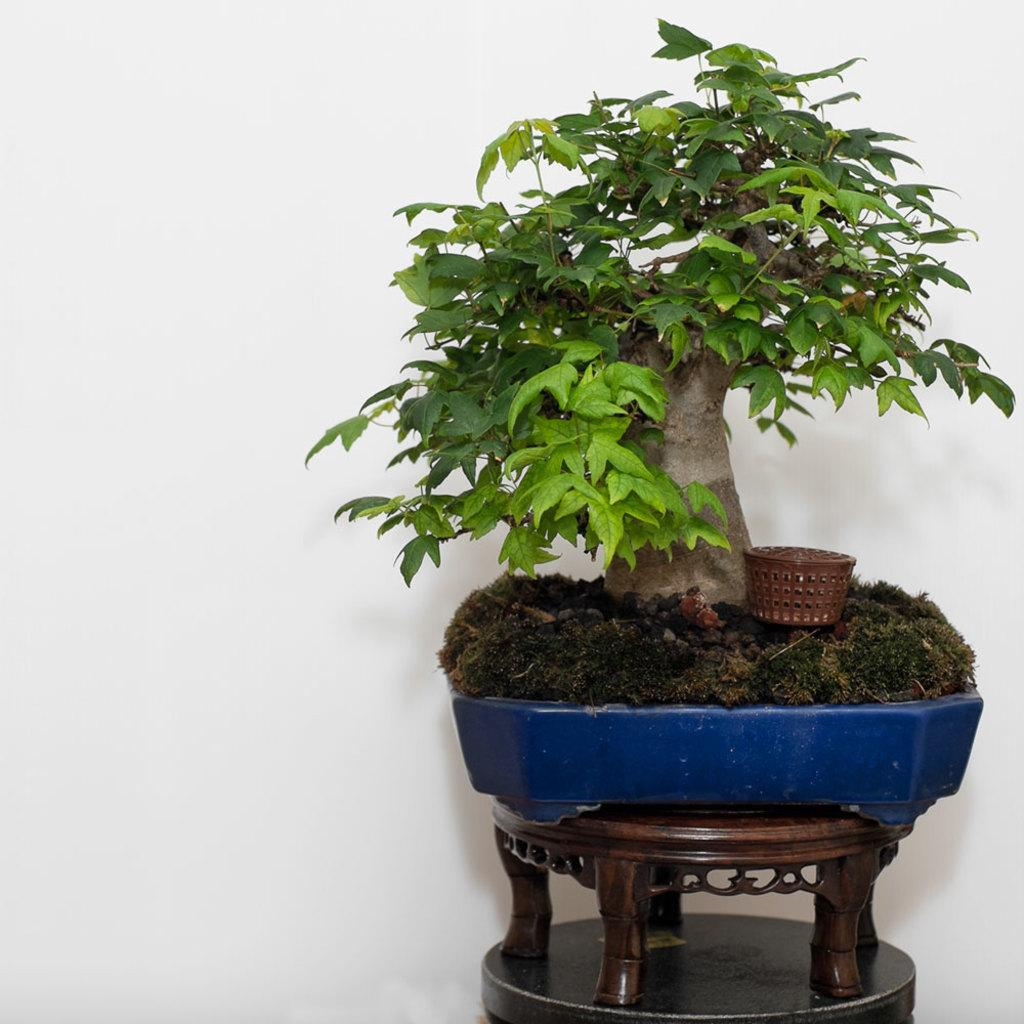What type of plant is in the pot in the image? There is a bonsai plant in the pot in the image. How is the pot with the bonsai plant positioned? The pot is on a stand. What other object is near the bonsai plant? There is a small box near the plant. What can be seen in the background of the image? There is a wall in the background of the image. How many firemen are visible in the image? There are no firemen present in the image. What type of branch is the bonsai plant growing on in the image? The bonsai plant is in a pot, not growing on a branch, and there is no branch visible in the image. 